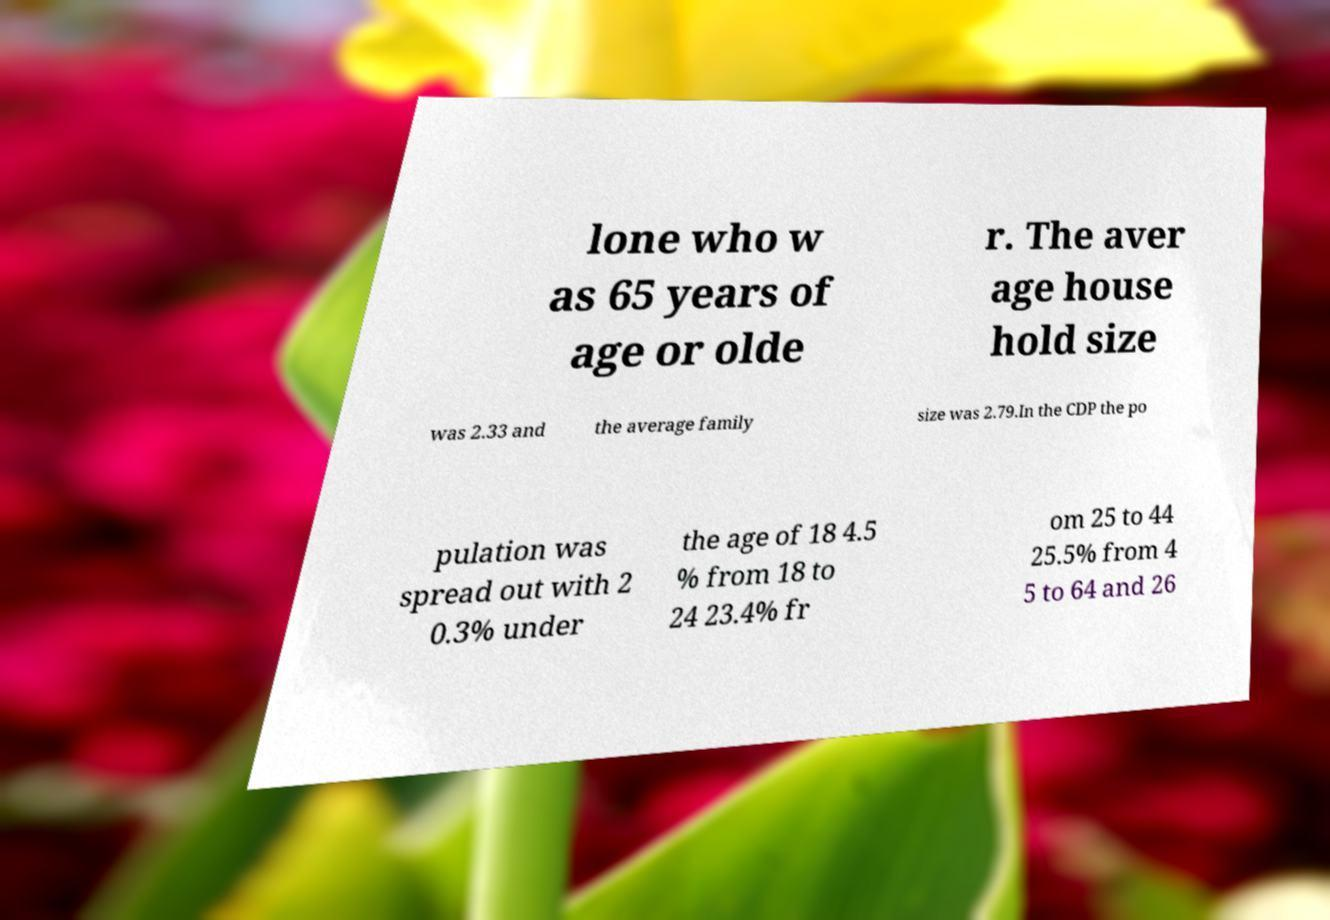What messages or text are displayed in this image? I need them in a readable, typed format. lone who w as 65 years of age or olde r. The aver age house hold size was 2.33 and the average family size was 2.79.In the CDP the po pulation was spread out with 2 0.3% under the age of 18 4.5 % from 18 to 24 23.4% fr om 25 to 44 25.5% from 4 5 to 64 and 26 